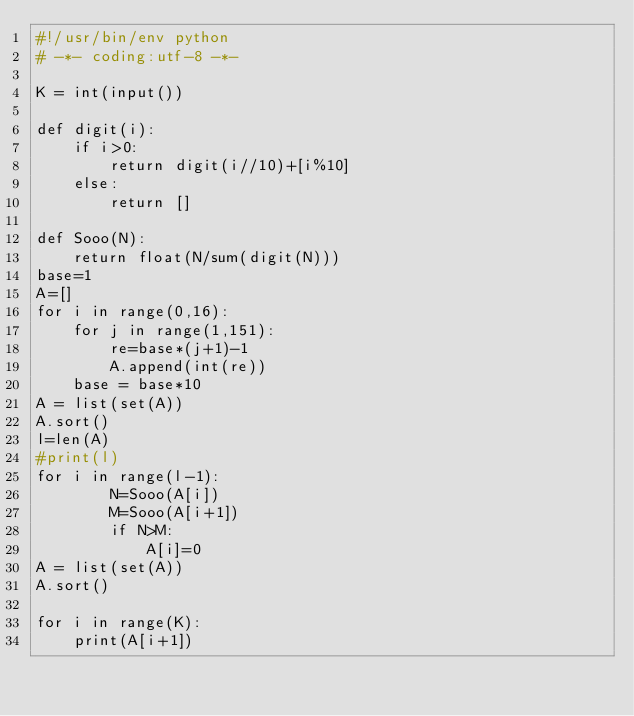<code> <loc_0><loc_0><loc_500><loc_500><_Python_>#!/usr/bin/env python
# -*- coding:utf-8 -*-

K = int(input())

def digit(i):
    if i>0:
        return digit(i//10)+[i%10]
    else:
        return []

def Sooo(N):
    return float(N/sum(digit(N)))
base=1
A=[]
for i in range(0,16):
    for j in range(1,151):
        re=base*(j+1)-1
        A.append(int(re))
    base = base*10
A = list(set(A))
A.sort()
l=len(A)
#print(l)
for i in range(l-1):
        N=Sooo(A[i])
        M=Sooo(A[i+1])
        if N>M:
            A[i]=0
A = list(set(A))
A.sort()

for i in range(K):
    print(A[i+1])</code> 